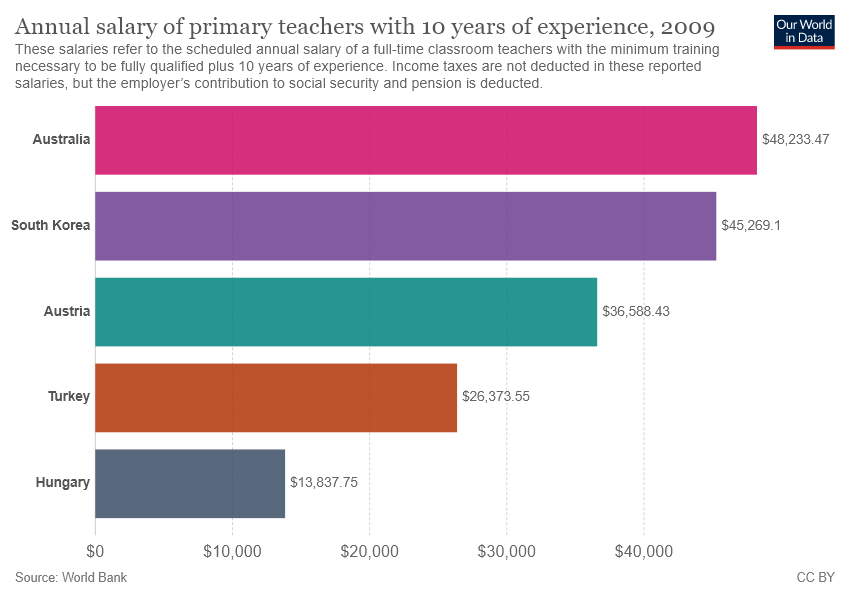Highlight a few significant elements in this photo. The color of the lowest salary bar is gray. The sum of Hungary and Turkey is not greater than Australia. 